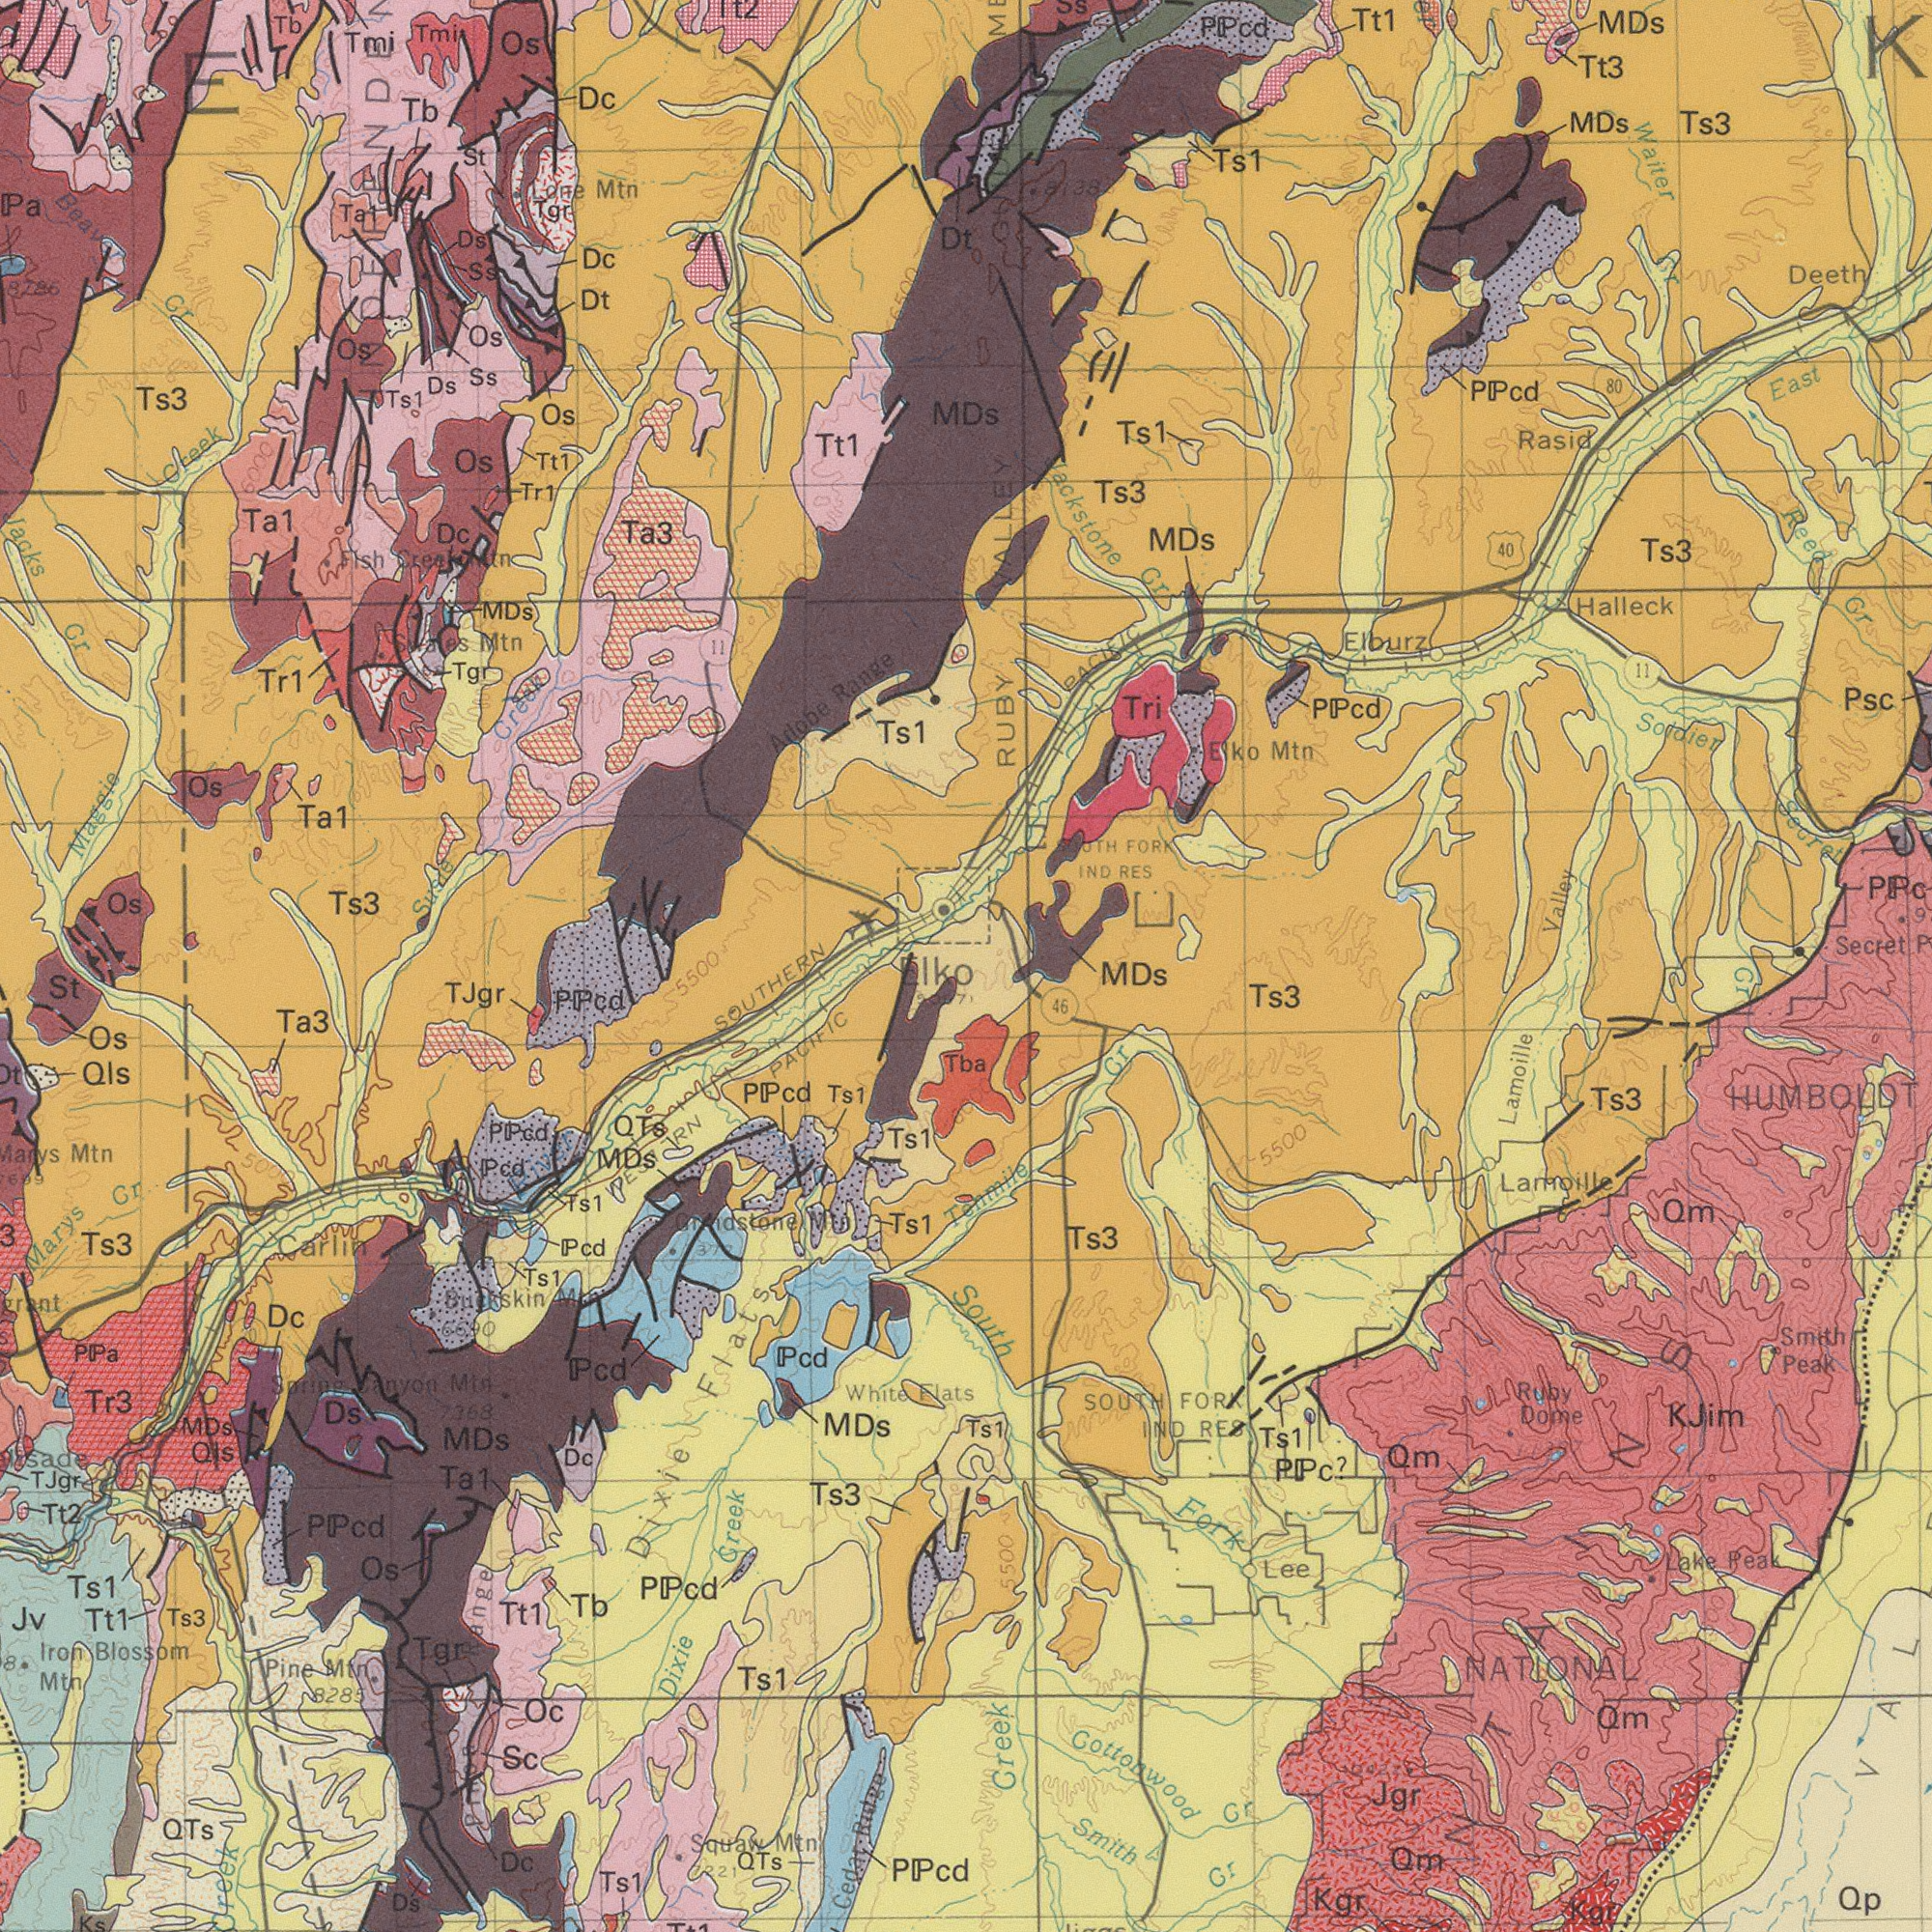What text appears in the bottom-right area of the image? Gottorwood HUMBOLDT Ts3 Creek Jgr Cr Smith Dome Ts3 Ts3 Cr RES Qp 46 NATIONAL Kgr Fork MDs Qm 5500 Ts1 FORK Qm Cr Smith Qm Lamoille Peak Ruby Lee Lake PPc? Peak Qm Kgr SOUTH South Tenmile KJim IND Ts1 VAL 5500 Lamoille Tba Cr 6000 500 10000 500 What text is shown in the bottom-left quadrant? Creek Ts3 Flats PPcd Blossom Ts1 Ts3 MDs PPcd SOUTHERN Marys TJgr Ts1 Ts1 Ta3 Ts1 QTs MDs Mtn MDs Ta1 PPcd Ts1 Dc Ts1 Dixie Dixie Pcd Pcd Squaw Mtn Mtn Dc Jv Pine MDs Qls White Pcd St Os Range Ts3 Tb Ts1 Os Tt1 QTs Tgr Iron PPa Mtn. Ts1 TJgr Tt2 Flats Pcd Oc Sc Cr PPcd PPcd Ds 8285 Tt1 Dc PPcd PACIFIC Mtn 7368 Canyon Ks 5000 QTs Qls Carlin Tr3 Ds Mtn 5500 6690 Buckskin Mtn Elko 370 WESTERN Tt1 7221 Ridge Cedar Soring What text can you see in the top-right section? Jackstone Waiter MDs Secret Secret Ts3 Ts3 MDs Halleck Valley Psc RES PPcd MDs Deeth Ts1 Rasid Ts3 East Elko Ts1 PPcd Cr Tt3 PPcd Tri Mtn Reed Elburz 80 FORK IND Soldier SOUTH Cr RUBY 40 11 MDs Tt1 8138 PACIFIC 6000 Cr VALLEY What text appears in the top-left area of the image? Jacks Ta3 Ts1 Ts3 Tt1 Ta1 Maggie Adobe Ta1 Range Ts3 Tr1 Tb Os MDs Ds Tt1 Tb Dc Os Cr Os Dc Mtn Tmi Dt Ss St Tr1 Os Tmi Os Lone Tgr Ta1 Dc Os Ts1 Mtn Tgr Ds Creek Beav Ss Os Cr Dt Fish 11 Creek 8286 Swates 6500 E Creek Mtn 6000 